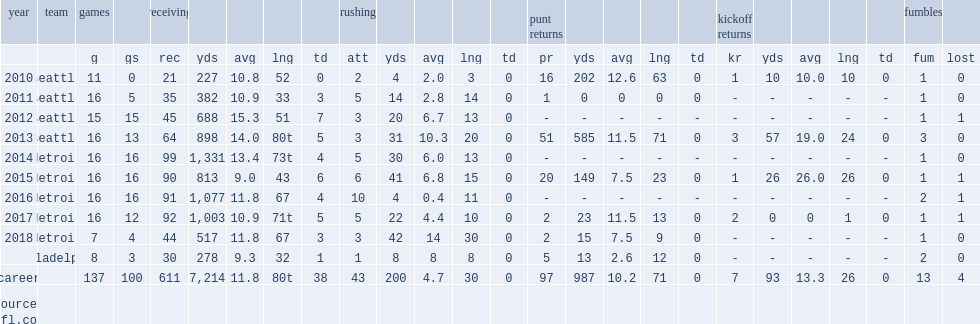How many receptions did golden tate receive in 2014? 99.0. How many yards did golden tate receive in 2014? 1331.0. 